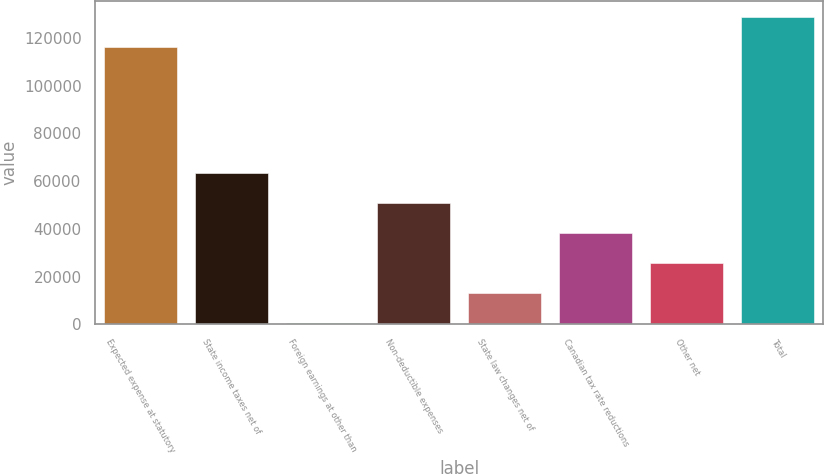Convert chart to OTSL. <chart><loc_0><loc_0><loc_500><loc_500><bar_chart><fcel>Expected expense at statutory<fcel>State income taxes net of<fcel>Foreign earnings at other than<fcel>Non-deductible expenses<fcel>State law changes net of<fcel>Canadian tax rate reductions<fcel>Other net<fcel>Total<nl><fcel>116430<fcel>63310<fcel>359<fcel>50719.8<fcel>12949.2<fcel>38129.6<fcel>25539.4<fcel>129020<nl></chart> 